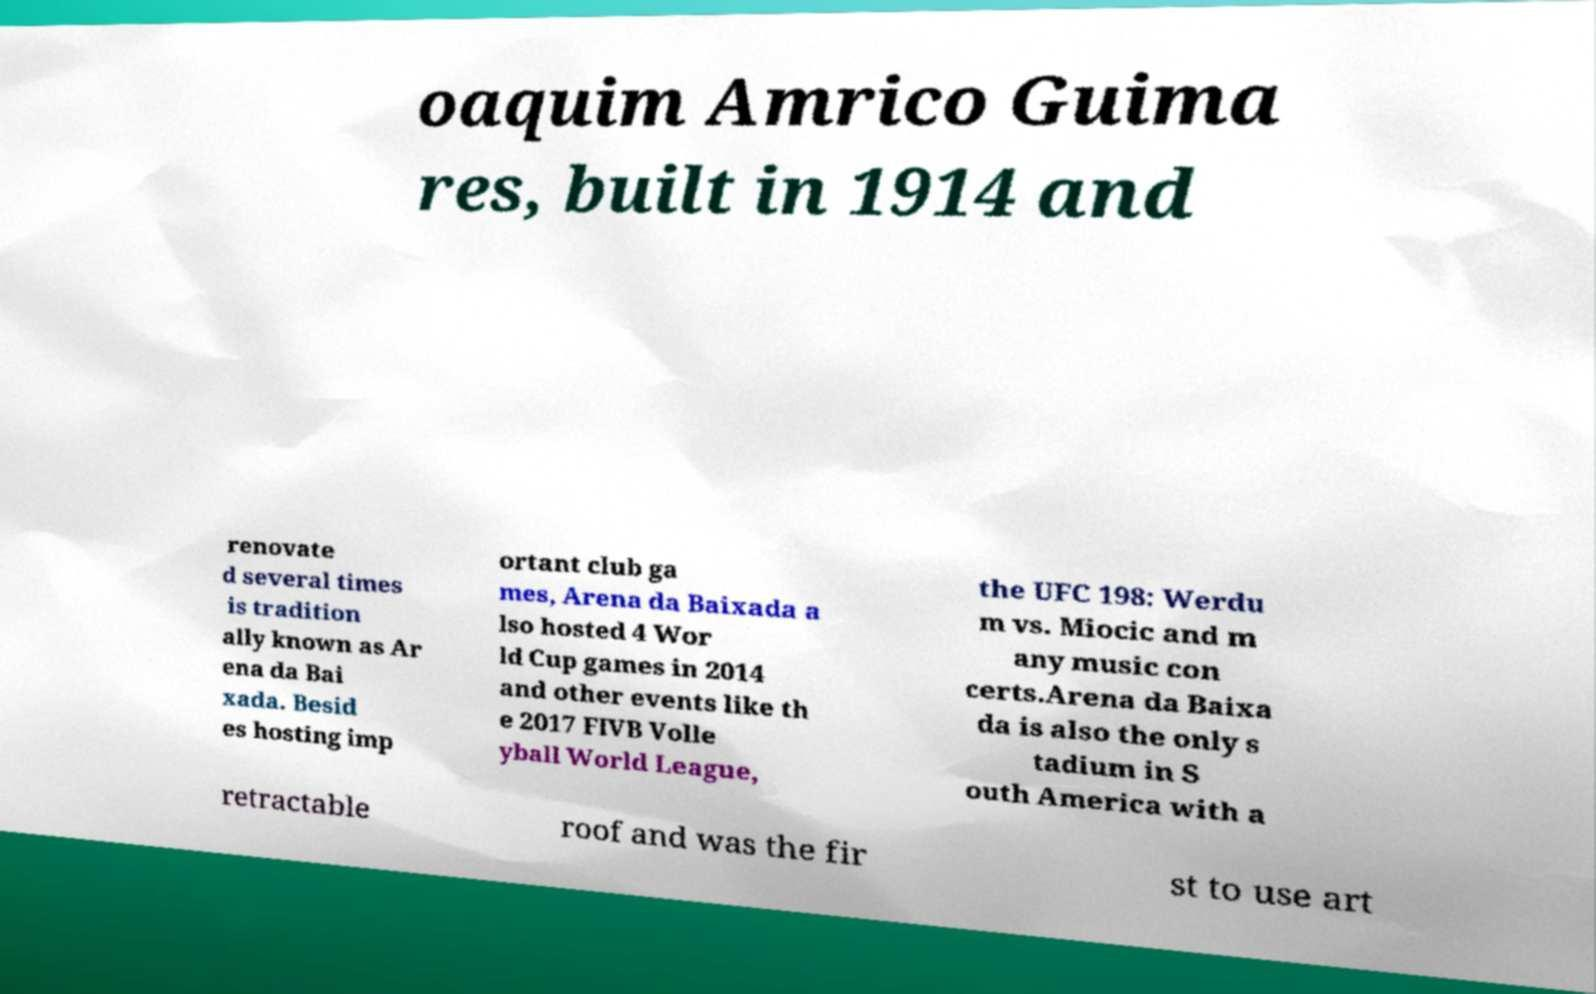I need the written content from this picture converted into text. Can you do that? oaquim Amrico Guima res, built in 1914 and renovate d several times is tradition ally known as Ar ena da Bai xada. Besid es hosting imp ortant club ga mes, Arena da Baixada a lso hosted 4 Wor ld Cup games in 2014 and other events like th e 2017 FIVB Volle yball World League, the UFC 198: Werdu m vs. Miocic and m any music con certs.Arena da Baixa da is also the only s tadium in S outh America with a retractable roof and was the fir st to use art 